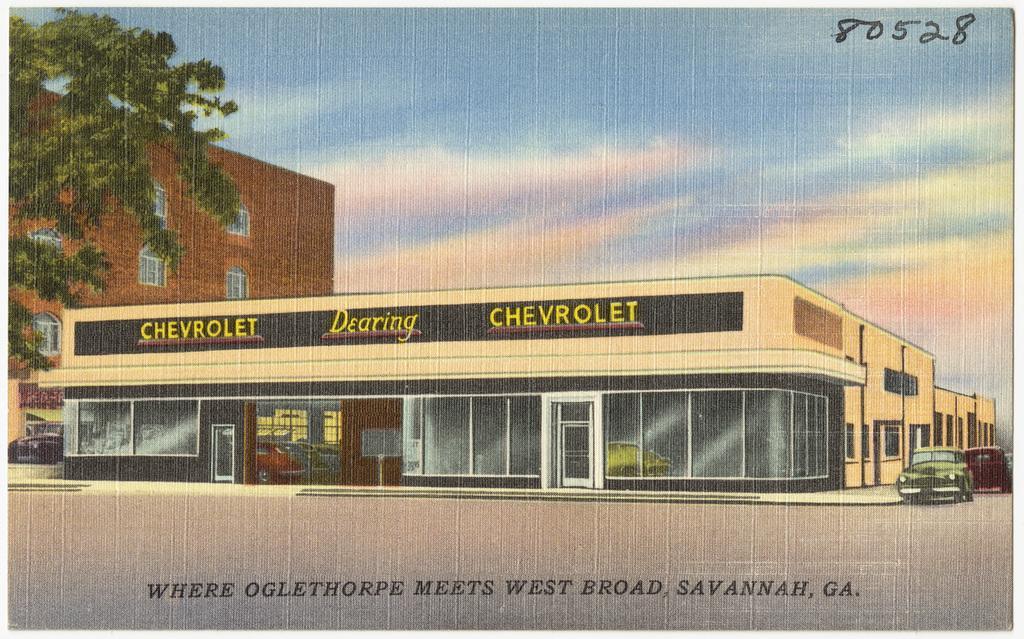How would you summarize this image in a sentence or two? In this image I can see depiction picture where I can see buildings, a tree, number of vehicles, clouds and the sky. I can also see something is written on the top right side and on the bottom side of the image. In the center I can see something is written on the building. 